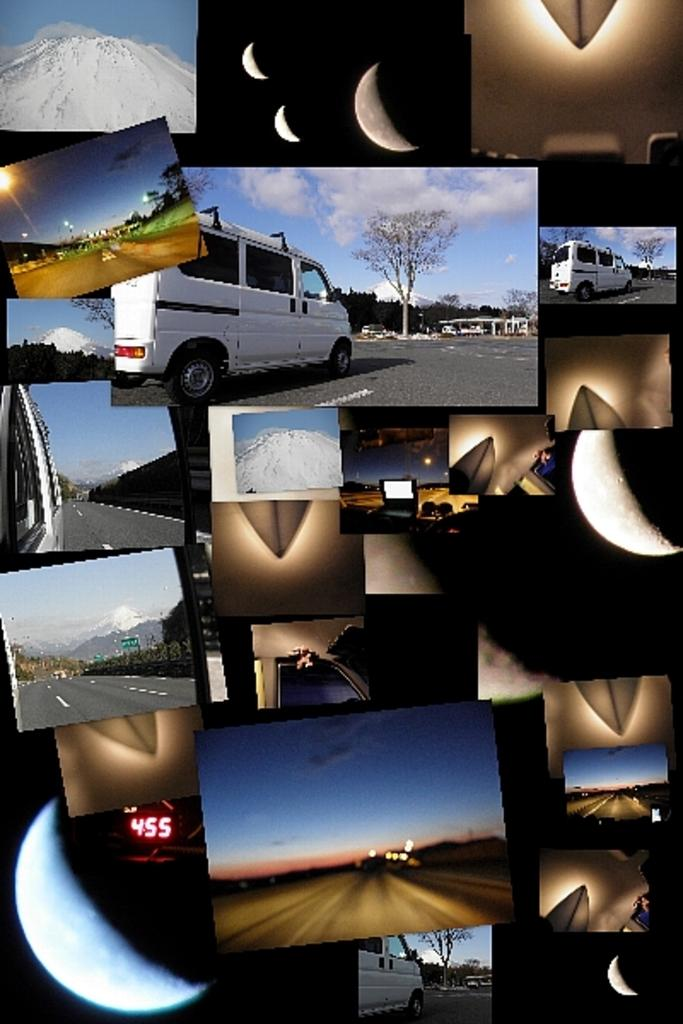What type of landscape elements are present in the image? The image contains pictures of roads, mountains, and trees. What else can be seen in the image besides landscape elements? The image contains pictures of vehicles and the moon. Can you describe the vehicles in the image? The image contains pictures of vehicles, but it does not specify the type or number of vehicles. What type of fang can be seen in the image? There is no fang present in the image; it contains pictures of roads, vehicles, the moon, mountains, and trees. How many businesses are visible in the image? There is no mention of businesses in the image; it contains pictures of roads, vehicles, the moon, mountains, and trees. 